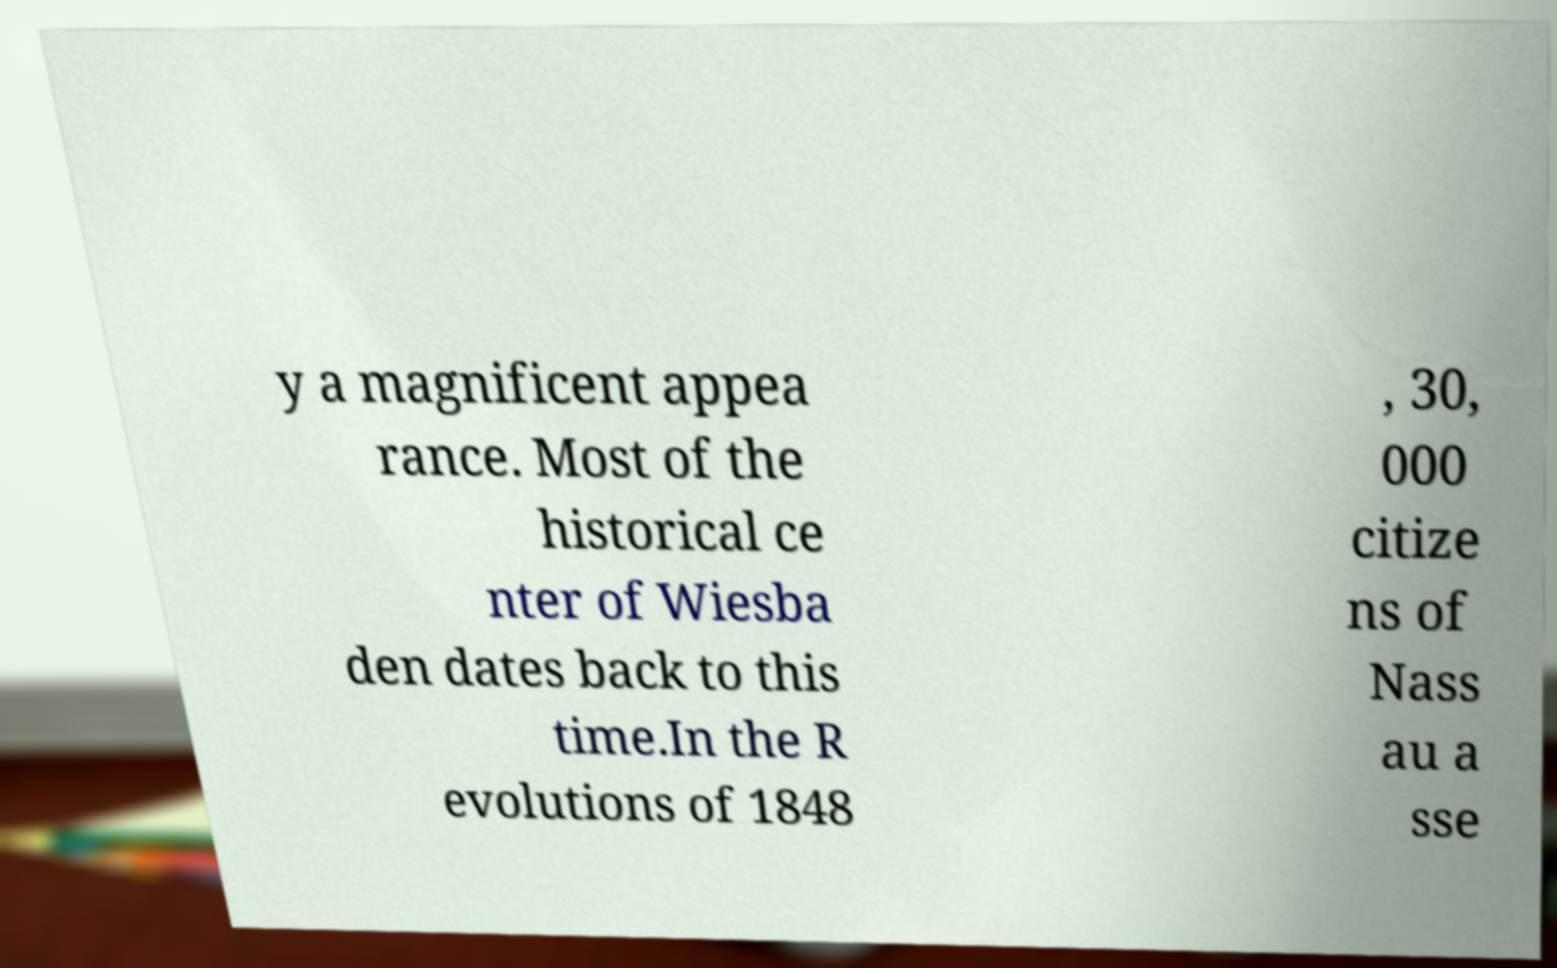Can you read and provide the text displayed in the image?This photo seems to have some interesting text. Can you extract and type it out for me? y a magnificent appea rance. Most of the historical ce nter of Wiesba den dates back to this time.In the R evolutions of 1848 , 30, 000 citize ns of Nass au a sse 